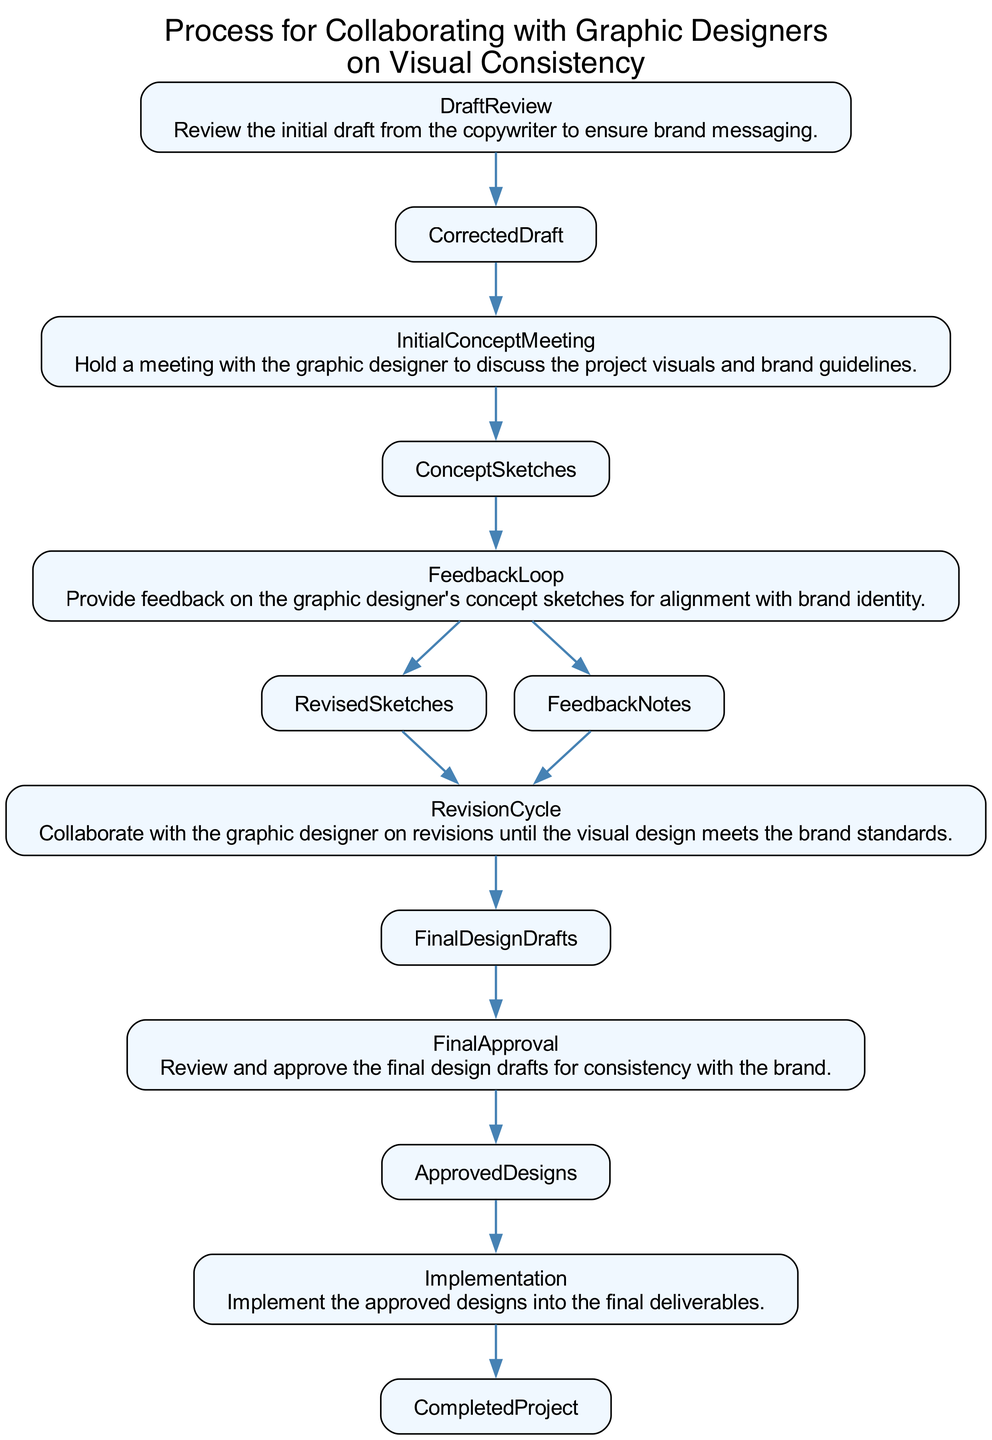What is the output of the DraftReview step? The DraftReview step produces a CorrectedDraft after reviewing the initial draft from the copywriter.
Answer: CorrectedDraft How many total nodes are present in the diagram? The diagram includes six nodes: DraftReview, InitialConceptMeeting, FeedbackLoop, RevisionCycle, FinalApproval, and Implementation.
Answer: Six What is the input required for the InitialConceptMeeting? The InitialConceptMeeting requires the CorrectedDraft as input to initiate the discussion on visuals.
Answer: CorrectedDraft What follows after the FeedbackLoop? The output of the FeedbackLoop leads to the RevisedSketches and FeedbackNotes, which then move on to the RevisionCycle.
Answer: RevisionCycle Which node does the Implementation step connect to? The Implementation step connects to the ApprovedDesigns, which are required for final project output.
Answer: ApprovedDesigns How many edges are coming out from the FinalApproval step? The FinalApproval step has one outgoing edge that connects to the ApprovedDesigns, as it only produces one output.
Answer: One What are the two outputs of the FeedbackLoop? The FeedbackLoop generates two outputs: RevisedSketches and FeedbackNotes, which are essential for further revisions.
Answer: RevisedSketches, FeedbackNotes Which step directly follows the InitialConceptMeeting? Following the InitialConceptMeeting, the FeedbackLoop step occurs to provide feedback on the concept sketches developed during the meeting.
Answer: FeedbackLoop What is the final deliverable produced by the Implementation step? The Implementation step produces the CompletedProject as the final deliverable integrating all approved designs.
Answer: CompletedProject 